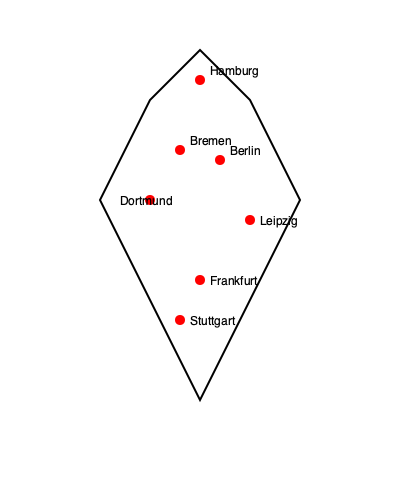Based on the geographical distribution of Bundesliga clubs shown on this simplified map of Germany, which region appears to have the highest concentration of top-tier football teams? To answer this question, we need to analyze the distribution of the marked cities on the map:

1. The map shows 7 cities represented by red dots:
   - Hamburg (north)
   - Bremen (northwest)
   - Berlin (northeast)
   - Dortmund (west)
   - Leipzig (east)
   - Frankfurt (central)
   - Stuttgart (southwest)

2. Looking at the geographical spread, we can see that most of the clubs are located in the western and central parts of Germany.

3. The area with the closest proximity between multiple clubs is in the western region, where we find:
   - Bremen
   - Dortmund
   - Frankfurt

4. This western cluster forms a rough triangle, with these cities being relatively close to each other compared to the distribution of other clubs on the map.

5. While there are other clubs spread across Germany (Hamburg in the north, Berlin in the east, Leipzig in the east, and Stuttgart in the southwest), they are more isolated and don't form as tight a cluster as the western group.

Therefore, based on this simplified map, the western region of Germany appears to have the highest concentration of Bundesliga clubs.
Answer: Western Germany 